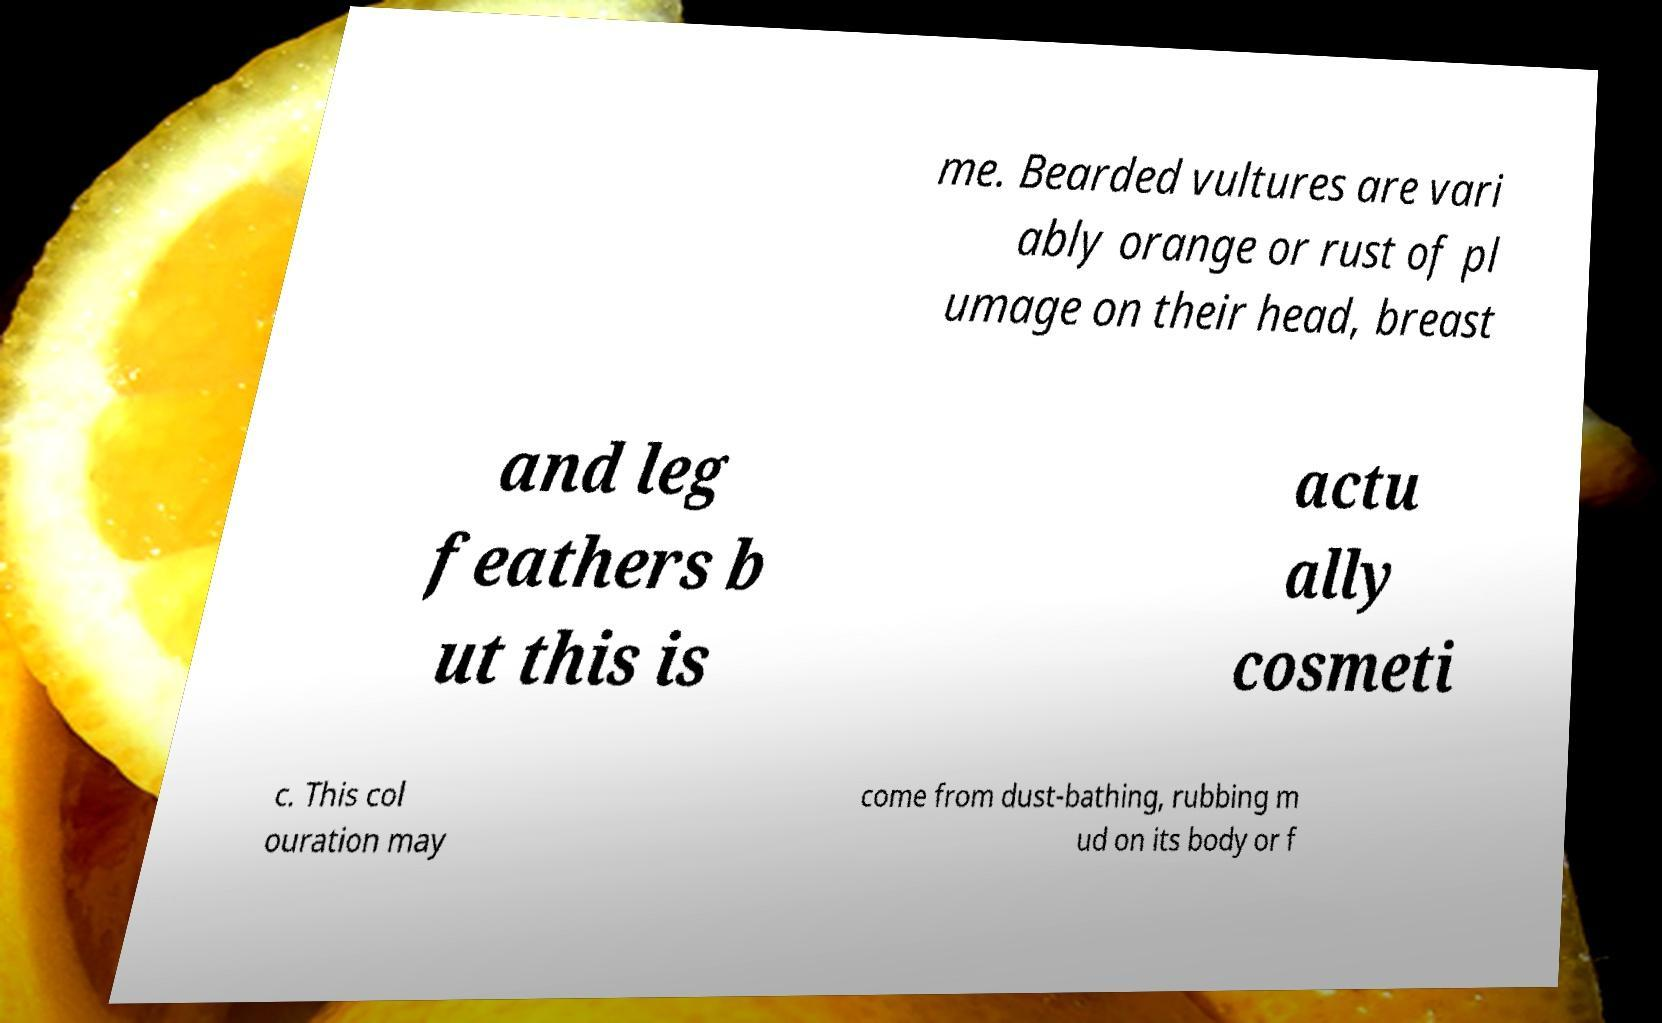Could you extract and type out the text from this image? me. Bearded vultures are vari ably orange or rust of pl umage on their head, breast and leg feathers b ut this is actu ally cosmeti c. This col ouration may come from dust-bathing, rubbing m ud on its body or f 